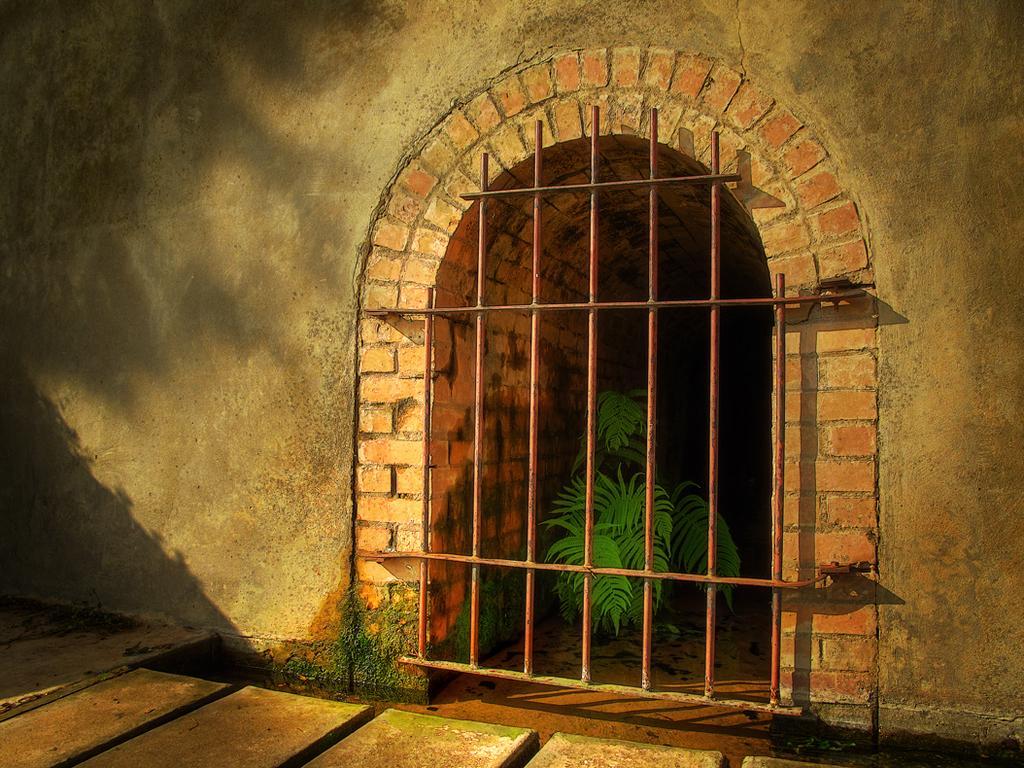Could you give a brief overview of what you see in this image? In front of the image there are wooden planks. There is a metal gate. Behind the metal gate there is a plant. There is a wall. 